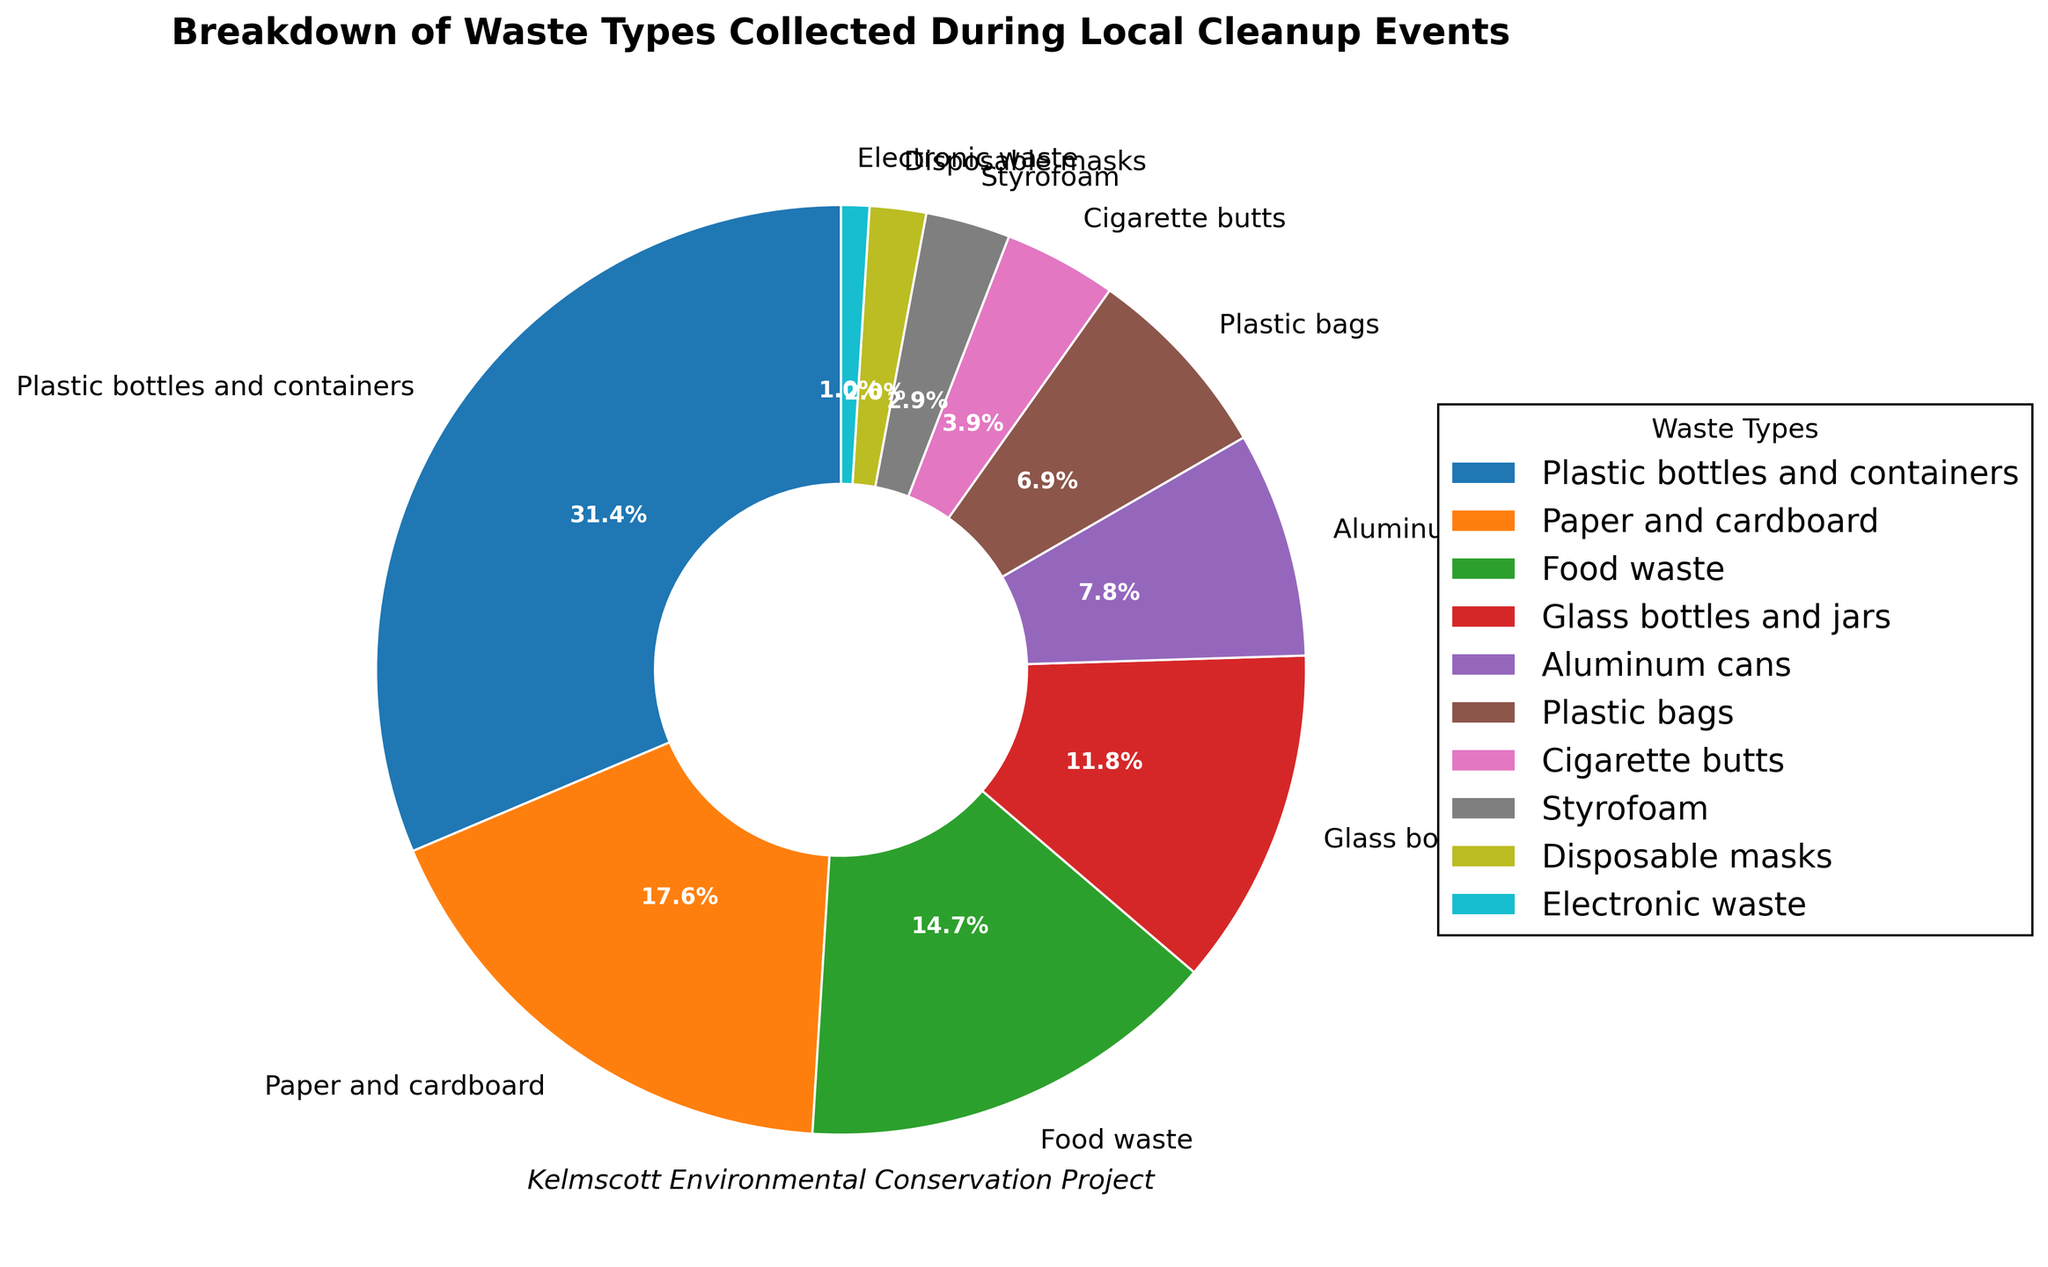What is the most common type of waste collected? The largest section of the pie chart corresponds to "Plastic bottles and containers" at 32%. This indicates that it is the most common type of waste collected.
Answer: Plastic bottles and containers What percentage of waste is made up of paper and cardboard items relative to plastic bottles and containers? The percentage of paper and cardboard items is 18%, and the percentage of plastic bottles and containers is 32%. The ratio is calculated by (18/32) * 100%, which is approximately 56.25%.
Answer: 56.25% How much more prevalent is food waste compared to disposable masks? Food waste accounts for 15% of the total waste, while disposable masks account for 2%. The difference is calculated as 15% - 2% = 13%.
Answer: 13% What is the combined percentage of waste from plastic bags and Styrofoam? The percentage of waste from plastic bags is 7%, and from Styrofoam is 3%. Adding these together, 7% + 3% = 10%.
Answer: 10% Which waste type is represented by the smallest section of the pie chart, and what is its percentage? The smallest section of the pie chart corresponds to "Electronic waste," which makes up 1% of the total waste.
Answer: Electronic waste, 1% What is the second most common type of waste collected? The second largest section of the pie chart represents "Paper and cardboard," which accounts for 18% of the waste.
Answer: Paper and cardboard How does the percentage of glass bottles and jars compare to aluminum cans? Glass bottles and jars represent 12% of the waste, while aluminum cans make up 8%. Therefore, glass bottles and jars are more prevalent by 4%.
Answer: Glass bottles and jars are 4% more prevalent What is the total percentage of waste made up by plastic (bottles and containers, bags) and Styrofoam combined? Plastic bottles and containers make up 32%, plastic bags make up 7%, and Styrofoam makes up 3%. Combined, these account for 32% + 7% + 3% = 42%.
Answer: 42% What is the difference in waste percentage between cigarette butts and disposable masks? Cigarette butts make up 4% of the waste, and disposable masks make up 2%. The difference is 4% - 2% = 2%.
Answer: 2% If we were to group plastic items together (bottles, bags, Styrofoam), what percentage of waste do they account for? Plastic bottles and containers are 32%, plastic bags are 7%, and Styrofoam is 3%. Grouping them together gives 32% + 7% + 3% = 42%.
Answer: 42% 